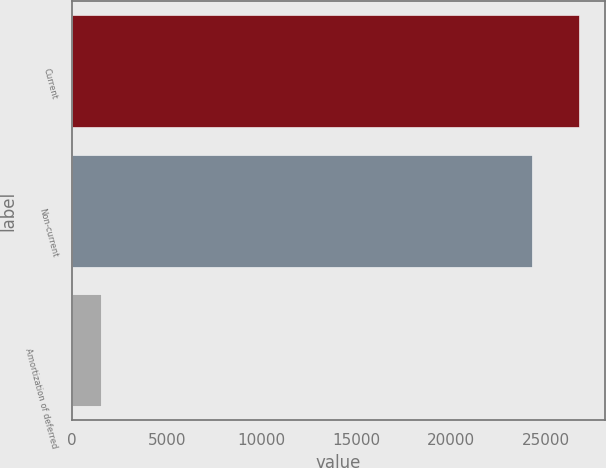Convert chart. <chart><loc_0><loc_0><loc_500><loc_500><bar_chart><fcel>Current<fcel>Non-current<fcel>Amortization of deferred<nl><fcel>26764.6<fcel>24256<fcel>1518<nl></chart> 